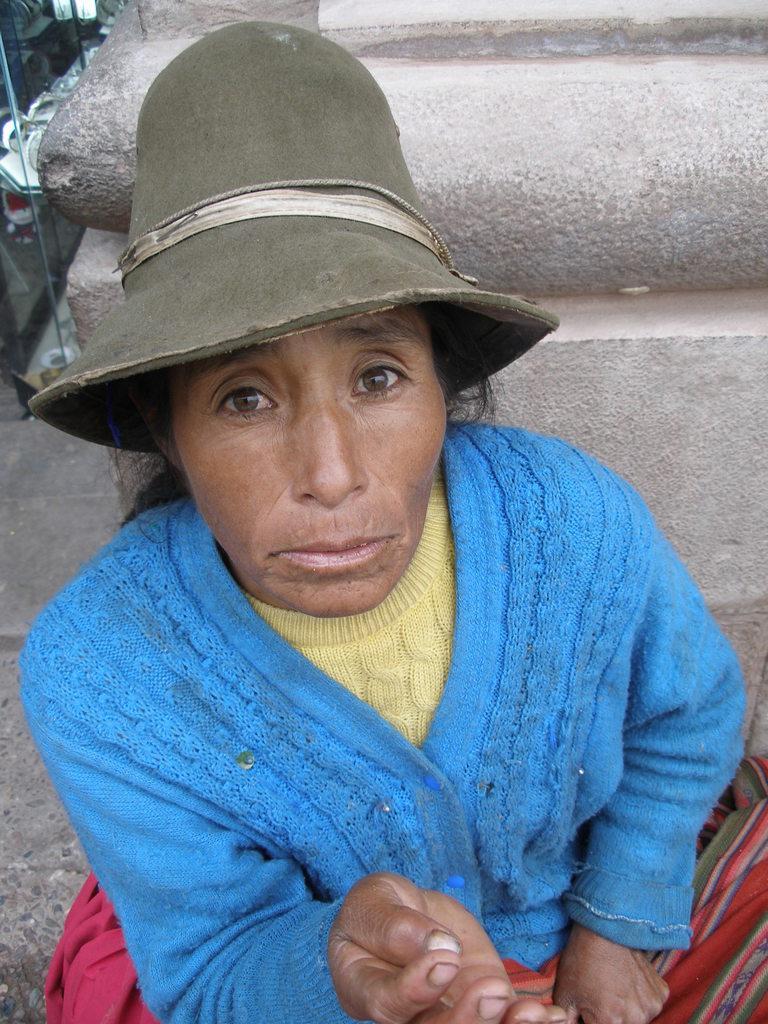Can you describe this image briefly? In this picture we can see one woman is sitting in front of the pillar. 